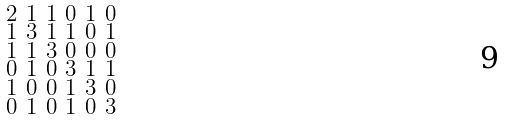Convert formula to latex. <formula><loc_0><loc_0><loc_500><loc_500>\begin{smallmatrix} 2 & 1 & 1 & 0 & 1 & 0 \\ 1 & 3 & 1 & 1 & 0 & 1 \\ 1 & 1 & 3 & 0 & 0 & 0 \\ 0 & 1 & 0 & 3 & 1 & 1 \\ 1 & 0 & 0 & 1 & 3 & 0 \\ 0 & 1 & 0 & 1 & 0 & 3 \end{smallmatrix}</formula> 